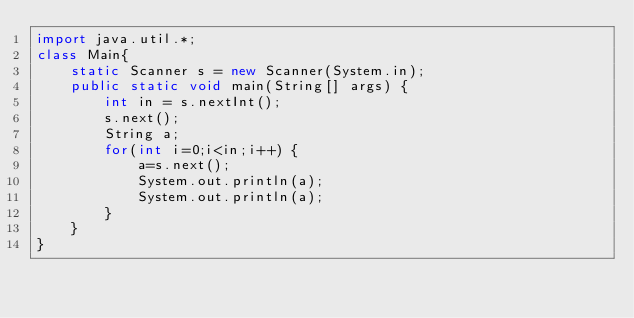Convert code to text. <code><loc_0><loc_0><loc_500><loc_500><_Java_>import java.util.*;
class Main{
	static Scanner s = new Scanner(System.in);
	public static void main(String[] args) {
		int in = s.nextInt();
		s.next();
		String a;
		for(int i=0;i<in;i++) {
			a=s.next();
			System.out.println(a);
			System.out.println(a);
		}
	}
}</code> 